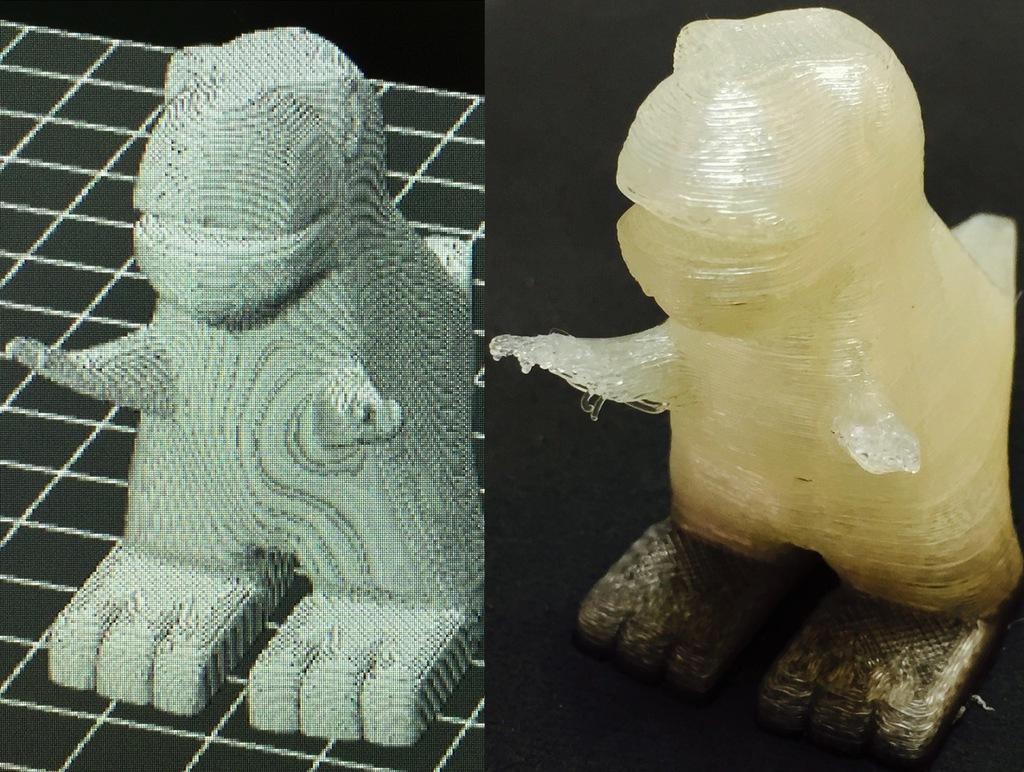What can be seen on the right side of the image? There is a sculpture on the right side of the image. What is depicted on the left side of the image? There is a depiction of the sculpture on the left side of the image. How does the beggar interact with the sculpture in the image? There is no beggar present in the image, so it is not possible to answer that question. 